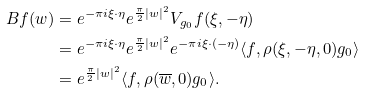Convert formula to latex. <formula><loc_0><loc_0><loc_500><loc_500>B f ( w ) & = e ^ { - \pi i \xi \cdot \eta } e ^ { \frac { \pi } { 2 } | w | ^ { 2 } } V _ { g _ { 0 } } f ( \xi , - \eta ) \\ & = e ^ { - \pi i \xi \cdot \eta } e ^ { \frac { \pi } { 2 } | w | ^ { 2 } } e ^ { - \pi i \xi \cdot ( - \eta ) } \langle f , \rho ( \xi , - \eta , 0 ) g _ { 0 } \rangle \\ & = e ^ { \frac { \pi } { 2 } | w | ^ { 2 } } \langle f , \rho ( \overline { w } , 0 ) g _ { 0 } \rangle .</formula> 